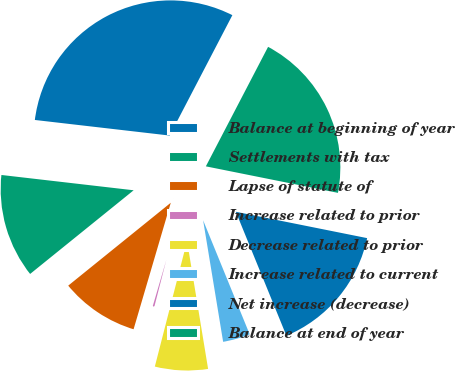<chart> <loc_0><loc_0><loc_500><loc_500><pie_chart><fcel>Balance at beginning of year<fcel>Settlements with tax<fcel>Lapse of statute of<fcel>Increase related to prior<fcel>Decrease related to prior<fcel>Increase related to current<fcel>Net increase (decrease)<fcel>Balance at end of year<nl><fcel>30.81%<fcel>12.65%<fcel>9.63%<fcel>0.55%<fcel>6.6%<fcel>3.57%<fcel>15.68%<fcel>20.51%<nl></chart> 